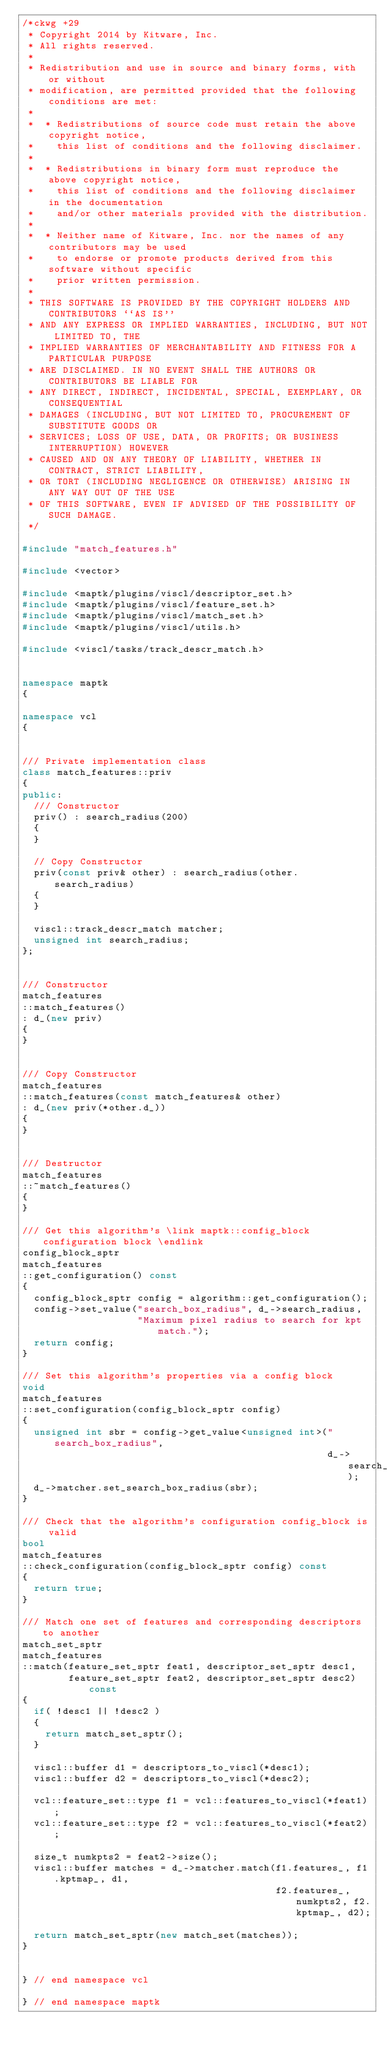Convert code to text. <code><loc_0><loc_0><loc_500><loc_500><_C++_>/*ckwg +29
 * Copyright 2014 by Kitware, Inc.
 * All rights reserved.
 *
 * Redistribution and use in source and binary forms, with or without
 * modification, are permitted provided that the following conditions are met:
 *
 *  * Redistributions of source code must retain the above copyright notice,
 *    this list of conditions and the following disclaimer.
 *
 *  * Redistributions in binary form must reproduce the above copyright notice,
 *    this list of conditions and the following disclaimer in the documentation
 *    and/or other materials provided with the distribution.
 *
 *  * Neither name of Kitware, Inc. nor the names of any contributors may be used
 *    to endorse or promote products derived from this software without specific
 *    prior written permission.
 *
 * THIS SOFTWARE IS PROVIDED BY THE COPYRIGHT HOLDERS AND CONTRIBUTORS ``AS IS''
 * AND ANY EXPRESS OR IMPLIED WARRANTIES, INCLUDING, BUT NOT LIMITED TO, THE
 * IMPLIED WARRANTIES OF MERCHANTABILITY AND FITNESS FOR A PARTICULAR PURPOSE
 * ARE DISCLAIMED. IN NO EVENT SHALL THE AUTHORS OR CONTRIBUTORS BE LIABLE FOR
 * ANY DIRECT, INDIRECT, INCIDENTAL, SPECIAL, EXEMPLARY, OR CONSEQUENTIAL
 * DAMAGES (INCLUDING, BUT NOT LIMITED TO, PROCUREMENT OF SUBSTITUTE GOODS OR
 * SERVICES; LOSS OF USE, DATA, OR PROFITS; OR BUSINESS INTERRUPTION) HOWEVER
 * CAUSED AND ON ANY THEORY OF LIABILITY, WHETHER IN CONTRACT, STRICT LIABILITY,
 * OR TORT (INCLUDING NEGLIGENCE OR OTHERWISE) ARISING IN ANY WAY OUT OF THE USE
 * OF THIS SOFTWARE, EVEN IF ADVISED OF THE POSSIBILITY OF SUCH DAMAGE.
 */

#include "match_features.h"

#include <vector>

#include <maptk/plugins/viscl/descriptor_set.h>
#include <maptk/plugins/viscl/feature_set.h>
#include <maptk/plugins/viscl/match_set.h>
#include <maptk/plugins/viscl/utils.h>

#include <viscl/tasks/track_descr_match.h>


namespace maptk
{

namespace vcl
{


/// Private implementation class
class match_features::priv
{
public:
  /// Constructor
  priv() : search_radius(200)
  {
  }

  // Copy Constructor
  priv(const priv& other) : search_radius(other.search_radius)
  {
  }

  viscl::track_descr_match matcher;
  unsigned int search_radius;
};


/// Constructor
match_features
::match_features()
: d_(new priv)
{
}


/// Copy Constructor
match_features
::match_features(const match_features& other)
: d_(new priv(*other.d_))
{
}


/// Destructor
match_features
::~match_features()
{
}

/// Get this algorithm's \link maptk::config_block configuration block \endlink
config_block_sptr
match_features
::get_configuration() const
{
  config_block_sptr config = algorithm::get_configuration();
  config->set_value("search_box_radius", d_->search_radius,
                    "Maximum pixel radius to search for kpt match.");
  return config;
}

/// Set this algorithm's properties via a config block
void
match_features
::set_configuration(config_block_sptr config)
{
  unsigned int sbr = config->get_value<unsigned int>("search_box_radius",
                                                     d_->search_radius);
  d_->matcher.set_search_box_radius(sbr);
}

/// Check that the algorithm's configuration config_block is valid
bool
match_features
::check_configuration(config_block_sptr config) const
{
  return true;
}

/// Match one set of features and corresponding descriptors to another
match_set_sptr
match_features
::match(feature_set_sptr feat1, descriptor_set_sptr desc1,
        feature_set_sptr feat2, descriptor_set_sptr desc2) const
{
  if( !desc1 || !desc2 )
  {
    return match_set_sptr();
  }

  viscl::buffer d1 = descriptors_to_viscl(*desc1);
  viscl::buffer d2 = descriptors_to_viscl(*desc2);

  vcl::feature_set::type f1 = vcl::features_to_viscl(*feat1);
  vcl::feature_set::type f2 = vcl::features_to_viscl(*feat2);

  size_t numkpts2 = feat2->size();
  viscl::buffer matches = d_->matcher.match(f1.features_, f1.kptmap_, d1,
                                            f2.features_, numkpts2, f2.kptmap_, d2);

  return match_set_sptr(new match_set(matches));
}


} // end namespace vcl

} // end namespace maptk
</code> 